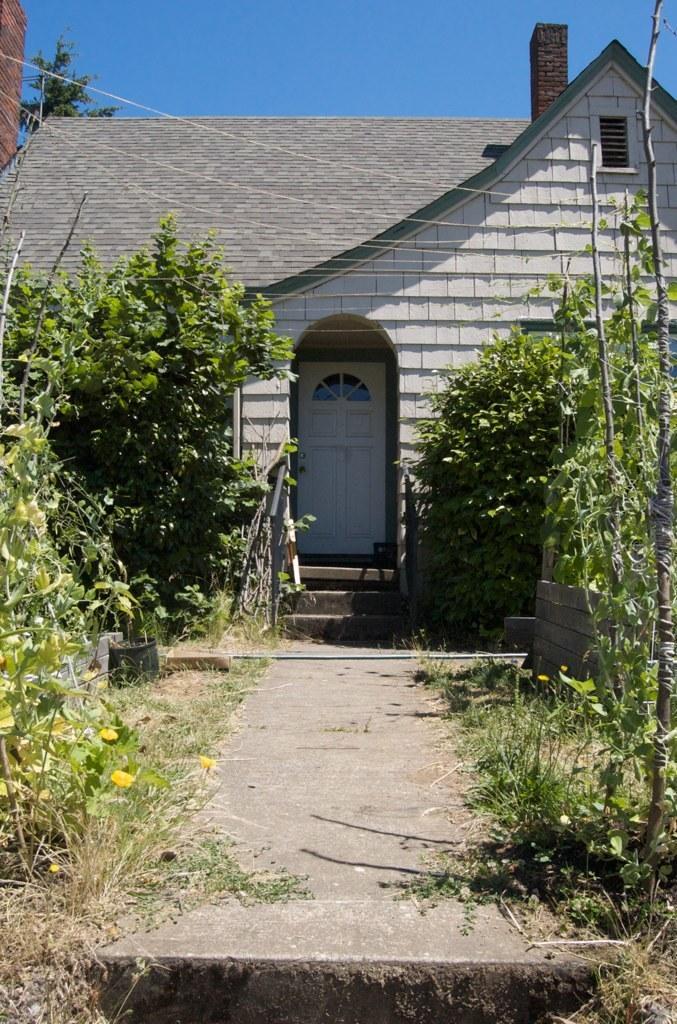How would you summarize this image in a sentence or two? Here we can see plants, trees, flowers, and a house. This is a door. In the background there is sky. 